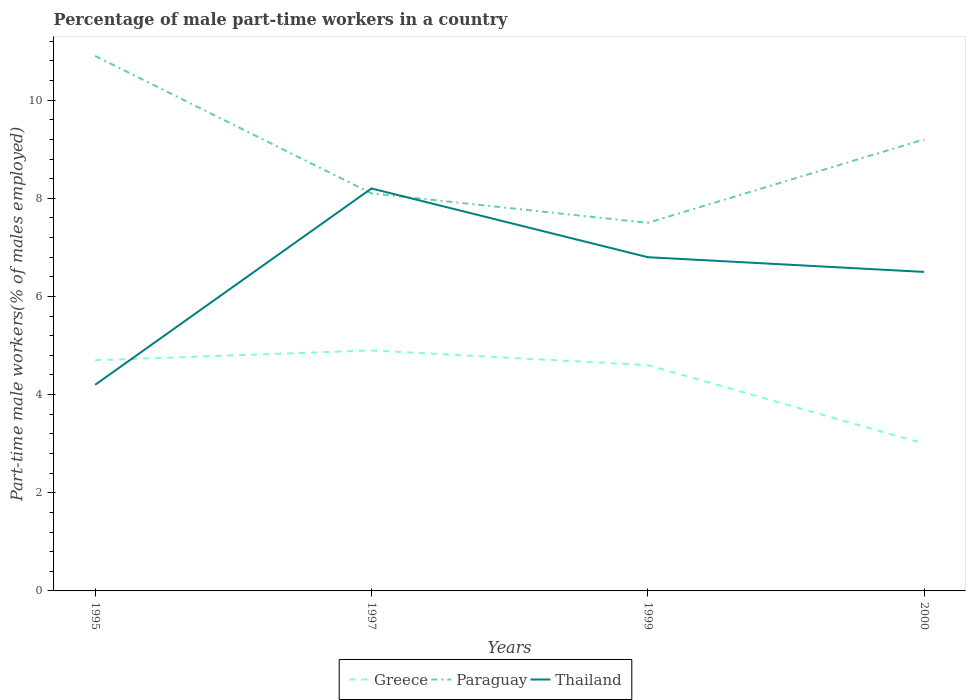How many different coloured lines are there?
Your response must be concise. 3. Does the line corresponding to Thailand intersect with the line corresponding to Greece?
Offer a terse response. Yes. In which year was the percentage of male part-time workers in Thailand maximum?
Give a very brief answer. 1995. What is the total percentage of male part-time workers in Greece in the graph?
Offer a terse response. 0.3. What is the difference between the highest and the second highest percentage of male part-time workers in Greece?
Offer a very short reply. 1.9. Is the percentage of male part-time workers in Paraguay strictly greater than the percentage of male part-time workers in Thailand over the years?
Your answer should be very brief. No. Are the values on the major ticks of Y-axis written in scientific E-notation?
Your response must be concise. No. Does the graph contain any zero values?
Provide a short and direct response. No. Does the graph contain grids?
Your answer should be very brief. No. Where does the legend appear in the graph?
Your answer should be very brief. Bottom center. What is the title of the graph?
Keep it short and to the point. Percentage of male part-time workers in a country. Does "Kosovo" appear as one of the legend labels in the graph?
Provide a short and direct response. No. What is the label or title of the Y-axis?
Offer a terse response. Part-time male workers(% of males employed). What is the Part-time male workers(% of males employed) in Greece in 1995?
Your answer should be very brief. 4.7. What is the Part-time male workers(% of males employed) in Paraguay in 1995?
Provide a short and direct response. 10.9. What is the Part-time male workers(% of males employed) in Thailand in 1995?
Your answer should be compact. 4.2. What is the Part-time male workers(% of males employed) of Greece in 1997?
Keep it short and to the point. 4.9. What is the Part-time male workers(% of males employed) in Paraguay in 1997?
Give a very brief answer. 8.1. What is the Part-time male workers(% of males employed) in Thailand in 1997?
Offer a very short reply. 8.2. What is the Part-time male workers(% of males employed) of Greece in 1999?
Make the answer very short. 4.6. What is the Part-time male workers(% of males employed) of Paraguay in 1999?
Your answer should be very brief. 7.5. What is the Part-time male workers(% of males employed) of Thailand in 1999?
Provide a short and direct response. 6.8. What is the Part-time male workers(% of males employed) of Paraguay in 2000?
Ensure brevity in your answer.  9.2. What is the Part-time male workers(% of males employed) in Thailand in 2000?
Your response must be concise. 6.5. Across all years, what is the maximum Part-time male workers(% of males employed) of Greece?
Provide a short and direct response. 4.9. Across all years, what is the maximum Part-time male workers(% of males employed) in Paraguay?
Ensure brevity in your answer.  10.9. Across all years, what is the maximum Part-time male workers(% of males employed) in Thailand?
Make the answer very short. 8.2. Across all years, what is the minimum Part-time male workers(% of males employed) of Thailand?
Provide a succinct answer. 4.2. What is the total Part-time male workers(% of males employed) of Paraguay in the graph?
Give a very brief answer. 35.7. What is the total Part-time male workers(% of males employed) of Thailand in the graph?
Provide a short and direct response. 25.7. What is the difference between the Part-time male workers(% of males employed) in Greece in 1995 and that in 1997?
Your answer should be very brief. -0.2. What is the difference between the Part-time male workers(% of males employed) in Paraguay in 1995 and that in 1997?
Make the answer very short. 2.8. What is the difference between the Part-time male workers(% of males employed) in Thailand in 1995 and that in 1997?
Provide a succinct answer. -4. What is the difference between the Part-time male workers(% of males employed) in Paraguay in 1995 and that in 2000?
Your answer should be very brief. 1.7. What is the difference between the Part-time male workers(% of males employed) of Thailand in 1995 and that in 2000?
Your response must be concise. -2.3. What is the difference between the Part-time male workers(% of males employed) of Paraguay in 1997 and that in 1999?
Offer a terse response. 0.6. What is the difference between the Part-time male workers(% of males employed) of Greece in 1997 and that in 2000?
Your response must be concise. 1.9. What is the difference between the Part-time male workers(% of males employed) of Paraguay in 1997 and that in 2000?
Provide a succinct answer. -1.1. What is the difference between the Part-time male workers(% of males employed) of Thailand in 1997 and that in 2000?
Make the answer very short. 1.7. What is the difference between the Part-time male workers(% of males employed) of Greece in 1999 and that in 2000?
Give a very brief answer. 1.6. What is the difference between the Part-time male workers(% of males employed) of Greece in 1995 and the Part-time male workers(% of males employed) of Thailand in 1997?
Provide a short and direct response. -3.5. What is the difference between the Part-time male workers(% of males employed) of Greece in 1995 and the Part-time male workers(% of males employed) of Thailand in 1999?
Provide a short and direct response. -2.1. What is the difference between the Part-time male workers(% of males employed) in Paraguay in 1995 and the Part-time male workers(% of males employed) in Thailand in 1999?
Provide a short and direct response. 4.1. What is the difference between the Part-time male workers(% of males employed) of Paraguay in 1995 and the Part-time male workers(% of males employed) of Thailand in 2000?
Ensure brevity in your answer.  4.4. What is the difference between the Part-time male workers(% of males employed) of Paraguay in 1997 and the Part-time male workers(% of males employed) of Thailand in 1999?
Provide a succinct answer. 1.3. What is the difference between the Part-time male workers(% of males employed) of Greece in 1997 and the Part-time male workers(% of males employed) of Thailand in 2000?
Ensure brevity in your answer.  -1.6. What is the difference between the Part-time male workers(% of males employed) in Paraguay in 1997 and the Part-time male workers(% of males employed) in Thailand in 2000?
Give a very brief answer. 1.6. What is the difference between the Part-time male workers(% of males employed) of Greece in 1999 and the Part-time male workers(% of males employed) of Paraguay in 2000?
Your answer should be compact. -4.6. What is the average Part-time male workers(% of males employed) in Paraguay per year?
Your answer should be very brief. 8.93. What is the average Part-time male workers(% of males employed) of Thailand per year?
Offer a terse response. 6.42. In the year 1995, what is the difference between the Part-time male workers(% of males employed) of Greece and Part-time male workers(% of males employed) of Paraguay?
Your answer should be compact. -6.2. In the year 1995, what is the difference between the Part-time male workers(% of males employed) of Paraguay and Part-time male workers(% of males employed) of Thailand?
Make the answer very short. 6.7. In the year 1997, what is the difference between the Part-time male workers(% of males employed) in Greece and Part-time male workers(% of males employed) in Thailand?
Your answer should be very brief. -3.3. In the year 1997, what is the difference between the Part-time male workers(% of males employed) of Paraguay and Part-time male workers(% of males employed) of Thailand?
Your answer should be compact. -0.1. In the year 1999, what is the difference between the Part-time male workers(% of males employed) of Paraguay and Part-time male workers(% of males employed) of Thailand?
Make the answer very short. 0.7. In the year 2000, what is the difference between the Part-time male workers(% of males employed) of Paraguay and Part-time male workers(% of males employed) of Thailand?
Give a very brief answer. 2.7. What is the ratio of the Part-time male workers(% of males employed) in Greece in 1995 to that in 1997?
Provide a succinct answer. 0.96. What is the ratio of the Part-time male workers(% of males employed) of Paraguay in 1995 to that in 1997?
Ensure brevity in your answer.  1.35. What is the ratio of the Part-time male workers(% of males employed) of Thailand in 1995 to that in 1997?
Offer a very short reply. 0.51. What is the ratio of the Part-time male workers(% of males employed) of Greece in 1995 to that in 1999?
Provide a short and direct response. 1.02. What is the ratio of the Part-time male workers(% of males employed) in Paraguay in 1995 to that in 1999?
Offer a very short reply. 1.45. What is the ratio of the Part-time male workers(% of males employed) in Thailand in 1995 to that in 1999?
Your answer should be compact. 0.62. What is the ratio of the Part-time male workers(% of males employed) in Greece in 1995 to that in 2000?
Provide a succinct answer. 1.57. What is the ratio of the Part-time male workers(% of males employed) of Paraguay in 1995 to that in 2000?
Your answer should be very brief. 1.18. What is the ratio of the Part-time male workers(% of males employed) of Thailand in 1995 to that in 2000?
Offer a very short reply. 0.65. What is the ratio of the Part-time male workers(% of males employed) in Greece in 1997 to that in 1999?
Your answer should be compact. 1.07. What is the ratio of the Part-time male workers(% of males employed) in Thailand in 1997 to that in 1999?
Give a very brief answer. 1.21. What is the ratio of the Part-time male workers(% of males employed) in Greece in 1997 to that in 2000?
Give a very brief answer. 1.63. What is the ratio of the Part-time male workers(% of males employed) in Paraguay in 1997 to that in 2000?
Provide a short and direct response. 0.88. What is the ratio of the Part-time male workers(% of males employed) in Thailand in 1997 to that in 2000?
Offer a terse response. 1.26. What is the ratio of the Part-time male workers(% of males employed) in Greece in 1999 to that in 2000?
Provide a short and direct response. 1.53. What is the ratio of the Part-time male workers(% of males employed) in Paraguay in 1999 to that in 2000?
Provide a succinct answer. 0.82. What is the ratio of the Part-time male workers(% of males employed) of Thailand in 1999 to that in 2000?
Your answer should be compact. 1.05. What is the difference between the highest and the second highest Part-time male workers(% of males employed) in Thailand?
Your answer should be compact. 1.4. What is the difference between the highest and the lowest Part-time male workers(% of males employed) of Greece?
Make the answer very short. 1.9. What is the difference between the highest and the lowest Part-time male workers(% of males employed) in Thailand?
Offer a very short reply. 4. 